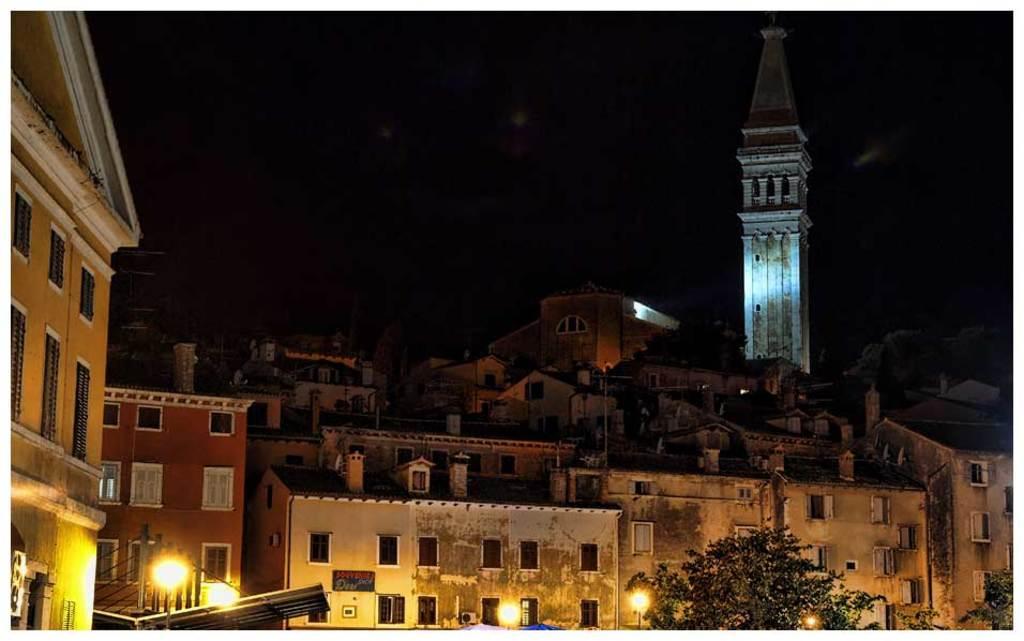Can you describe this image briefly? At the bottom of the picture, we see trees and street lights. On the left side, we see a building in yellow color. There are buildings in the background. On the right side, we see a monument. In the background, it is black in color. This picture might be clicked in the dark. 